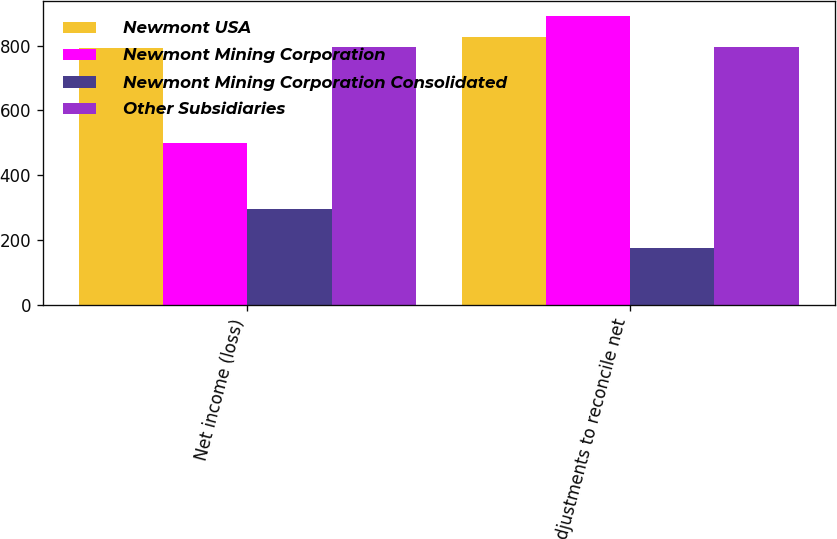Convert chart to OTSL. <chart><loc_0><loc_0><loc_500><loc_500><stacked_bar_chart><ecel><fcel>Net income (loss)<fcel>Adjustments to reconcile net<nl><fcel>Newmont USA<fcel>791<fcel>826<nl><fcel>Newmont Mining Corporation<fcel>500<fcel>892<nl><fcel>Newmont Mining Corporation Consolidated<fcel>295<fcel>176<nl><fcel>Other Subsidiaries<fcel>795<fcel>795<nl></chart> 